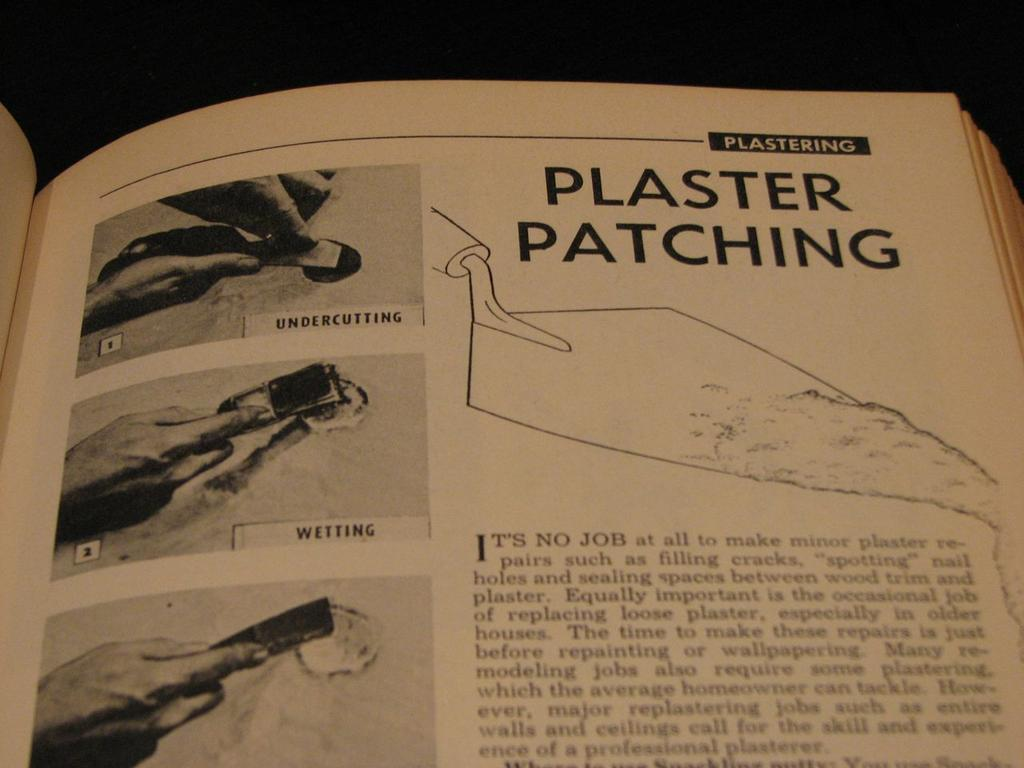<image>
Share a concise interpretation of the image provided. A book open to a page titled Plaster Patching with images of someone plastering. 